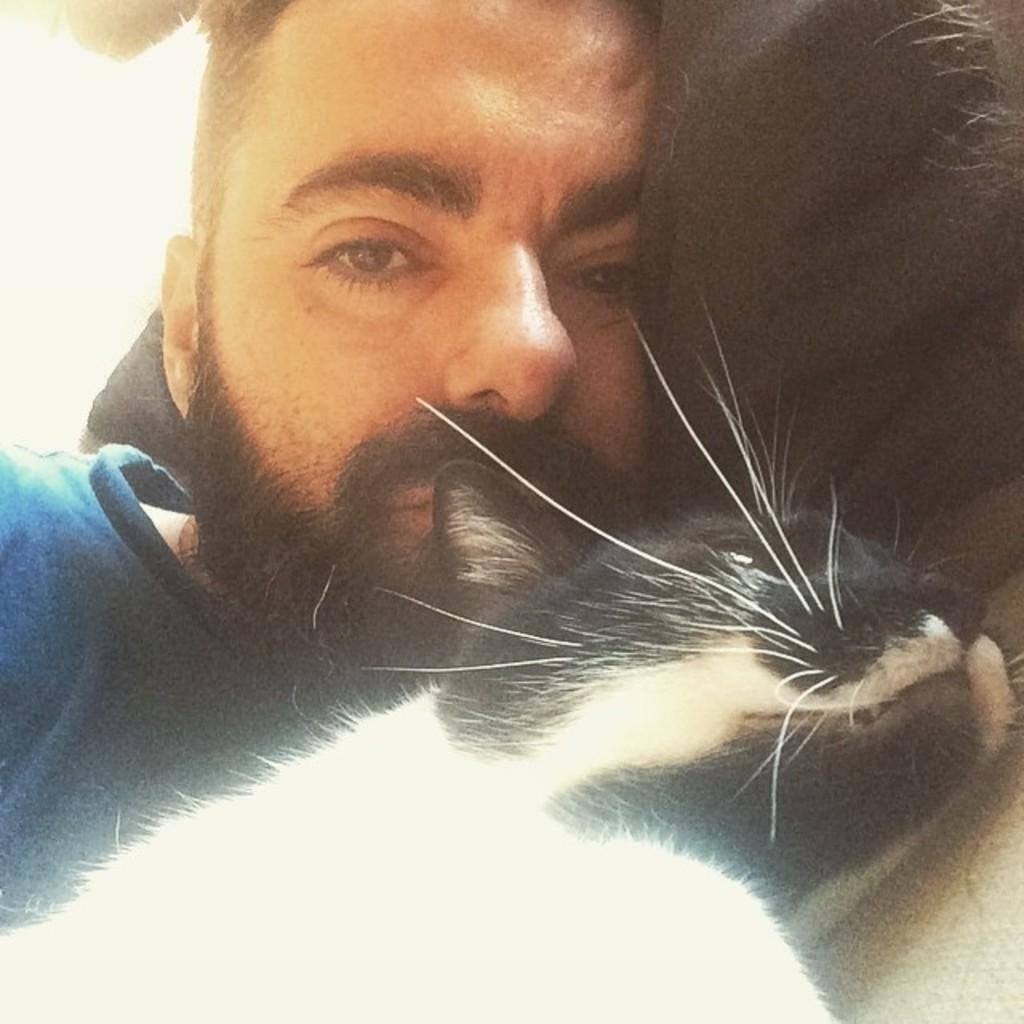What is the main subject of the image? The main subject of the image is a man. What is the man doing in the image? The man is sleeping in the image. What is the man wearing in the image? The man is wearing a blue T-shirt in the image. What other living creature is present in the image? There is a cat in the image. What is the appearance of the cat in the image? The cat is black and white in color. Where are the man and the cat located in the image? Both the man and the cat are sleeping on the floor in the image. What type of cord is being used by the man to communicate with the cat in the image? There is no cord or communication between the man and the cat in the image; they are both simply sleeping on the floor. 